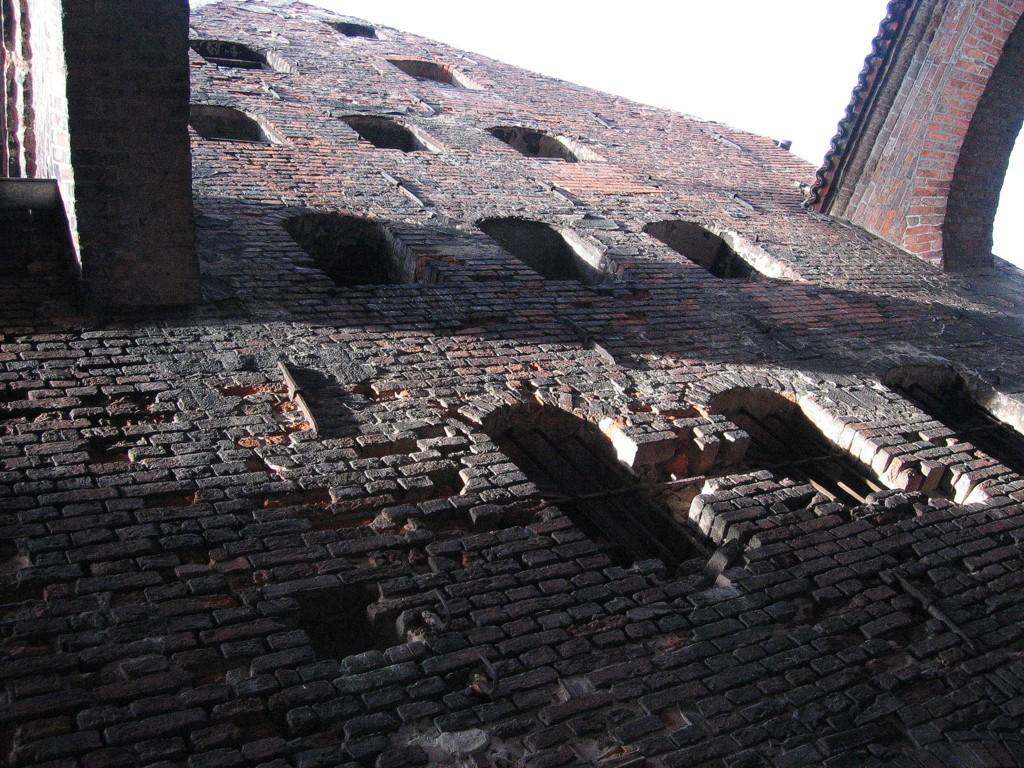What type of structure is present in the image? There is a building in the image. How many bridges can be seen in the image? There are two bridges in the image. What feature is present in the building that allows light to enter? The image contains windows. What is the weather like in the image? The sky is clear in the image, suggesting good weather. What type of list can be seen hanging on the wall in the image? There is no list present in the image; it only contains a building, two bridges, windows, and a clear sky. What type of pleasure can be seen being experienced by the people in the image? There are no people present in the image, so it is impossible to determine if they are experiencing any pleasure. 